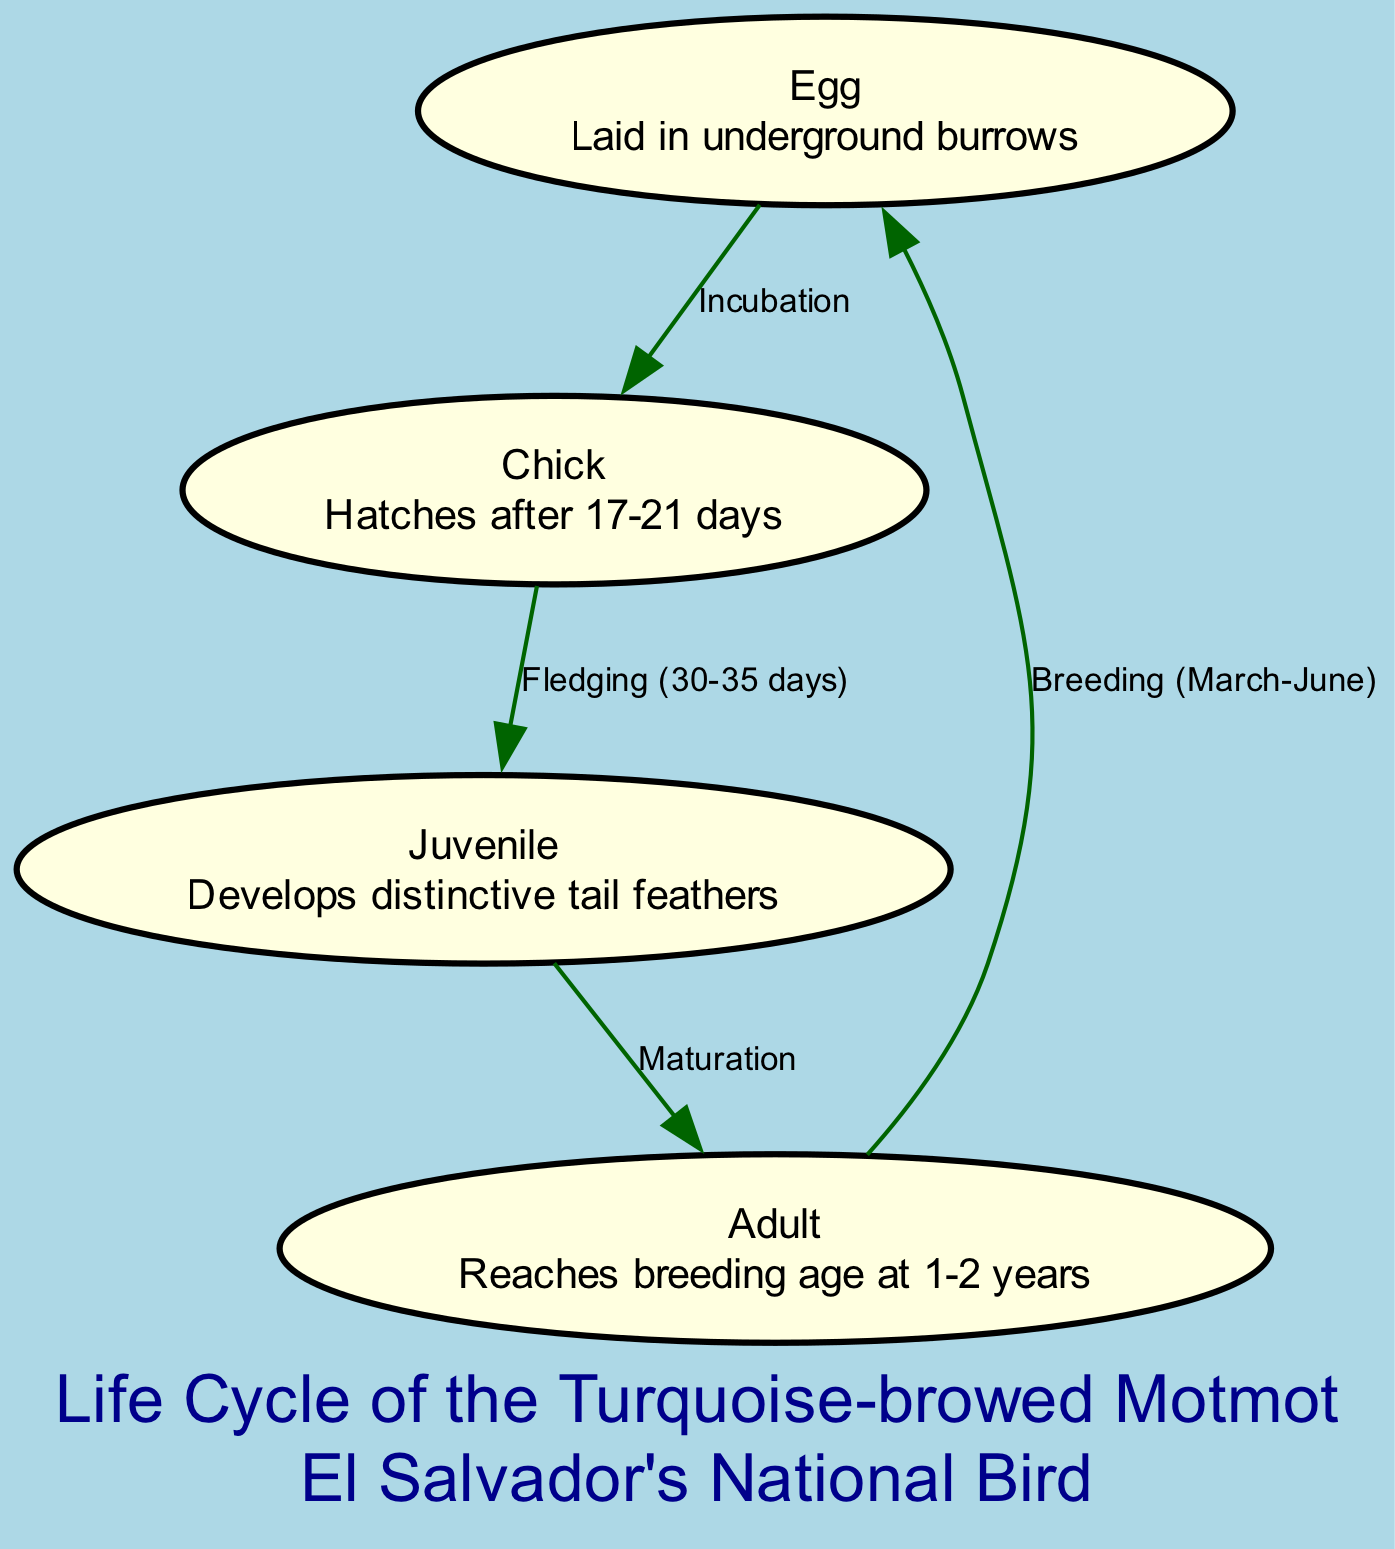What is the first stage of the life cycle? The diagram starts with the node labeled "Egg," indicating that this is the first stage of the life cycle of the Turquoise-browed Motmot.
Answer: Egg How many days does it take for the egg to hatch? The diagram shows that the egg hatches after 17-21 days. This information is included in the description of the "Chick" node.
Answer: 17-21 days What is the last stage before it breeds? To determine the last stage before breeding, we trace from the "Adult" node back to the "Egg" node, noting that after reaching adulthood, the Motmot can breed. The last stage before breeding is "Adult."
Answer: Adult How long does fledging take? The "Chick" node describes that the fledging process lasts 30-35 days before the chick becomes a juvenile. This is shown in the edge connecting the "Chick" to the "Juvenile."
Answer: 30-35 days During what months does breeding occur? The edge leading from the "Adult" node to the "Egg" node is labeled with "Breeding (March-June)," indicating the time frame within which breeding occurs for the Turquoise-browed Motmot.
Answer: March-June What developmental feature is notable in the juvenile stage? In the diagram, the description of the "Juvenile" node states that it develops distinctive tail feathers, which is a key feature during this stage.
Answer: Distinctive tail feathers How many nodes represent stages of development in this life cycle? The diagram contains four nodes: "Egg," "Chick," "Juvenile," and "Adult." Therefore, we can conclude that there are four stages of development represented in this life cycle.
Answer: Four What is the relationship between the Adult and Egg stages? In the diagram, the edge connecting the "Adult" node to the "Egg" node is labeled "Breeding (March-June)." This implies that adults produce eggs during the breeding season, highlighting their relationship.
Answer: Breeding (March-June) What is the tropical habitat mentioned in the background? The background description of the diagram states that the typical habitat for the Turquoise-browed Motmot is tropical dry forests and coffee plantations. This defines the environment where these birds thrive.
Answer: Tropical dry forests and coffee plantations 